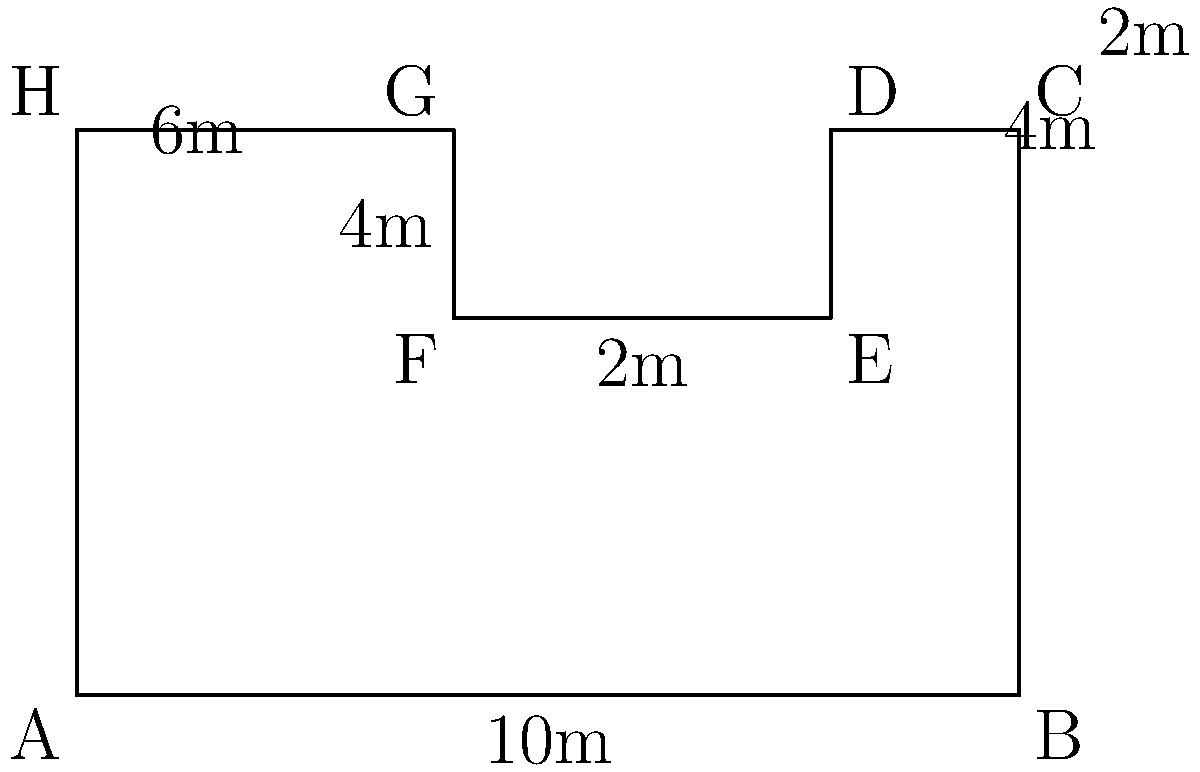As a trade show organizer, you're planning an event in an irregularly shaped exhibition hall. The hall's floor plan is shown in the diagram above. What is the total floor space of this exhibition hall in square meters? To calculate the total floor space, we need to break down the irregular shape into simpler geometric shapes and sum their areas. Let's approach this step-by-step:

1. The hall can be divided into a large rectangle (ABFGH) and two smaller rectangles (FCDE and DEFG).

2. Calculate the area of the large rectangle (ABFGH):
   Length = 10m, Width = 4m
   Area_1 = $10m \times 4m = 40m^2$

3. Calculate the area of rectangle FCDE:
   Length = 4m, Width = 2m
   Area_2 = $4m \times 2m = 8m^2$

4. Calculate the area of rectangle DEFG:
   Length = 2m, Width = 2m
   Area_3 = $2m \times 2m = 4m^2$

5. Sum up all the areas:
   Total Area = Area_1 + Area_2 + Area_3
               = $40m^2 + 8m^2 + 4m^2$
               = $52m^2$

Therefore, the total floor space of the exhibition hall is 52 square meters.
Answer: $52m^2$ 